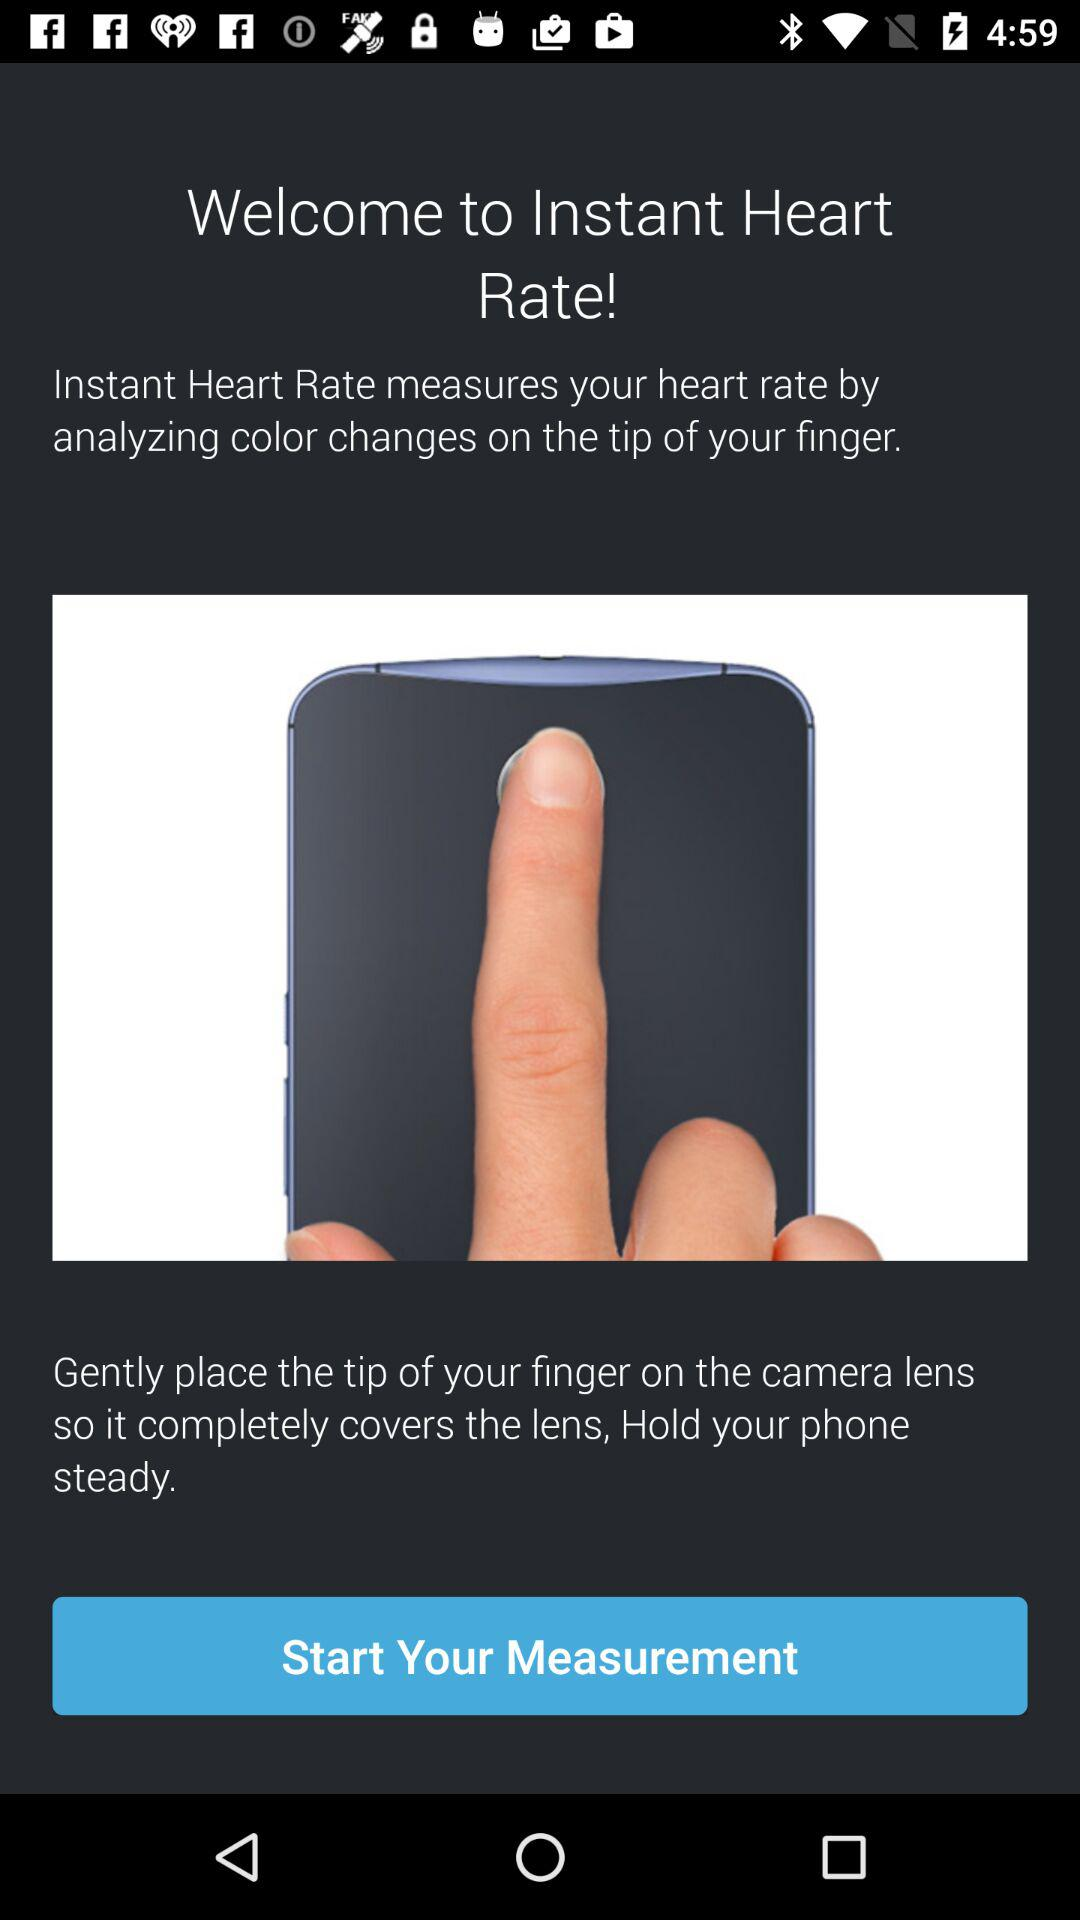What are the instructions given to measure the heart rate? The instructions are "Gently place the tip of your finger on the camera lens so it completely covers the lens, Hold your phone steady.". 